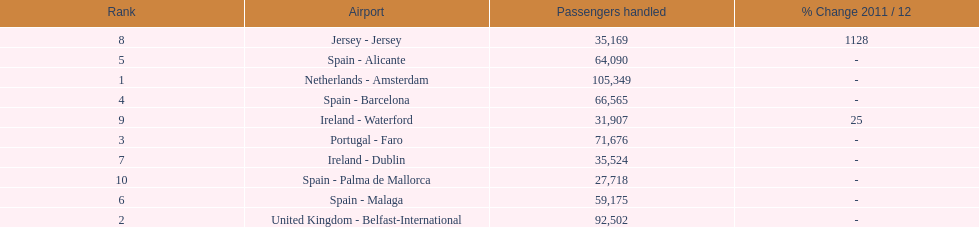Which airport has no more than 30,000 passengers handled among the 10 busiest routes to and from london southend airport in 2012? Spain - Palma de Mallorca. 